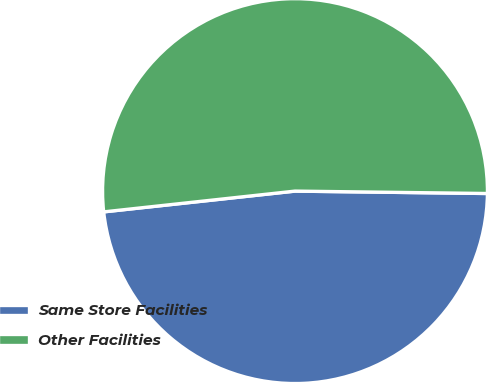<chart> <loc_0><loc_0><loc_500><loc_500><pie_chart><fcel>Same Store Facilities<fcel>Other Facilities<nl><fcel>48.08%<fcel>51.92%<nl></chart> 